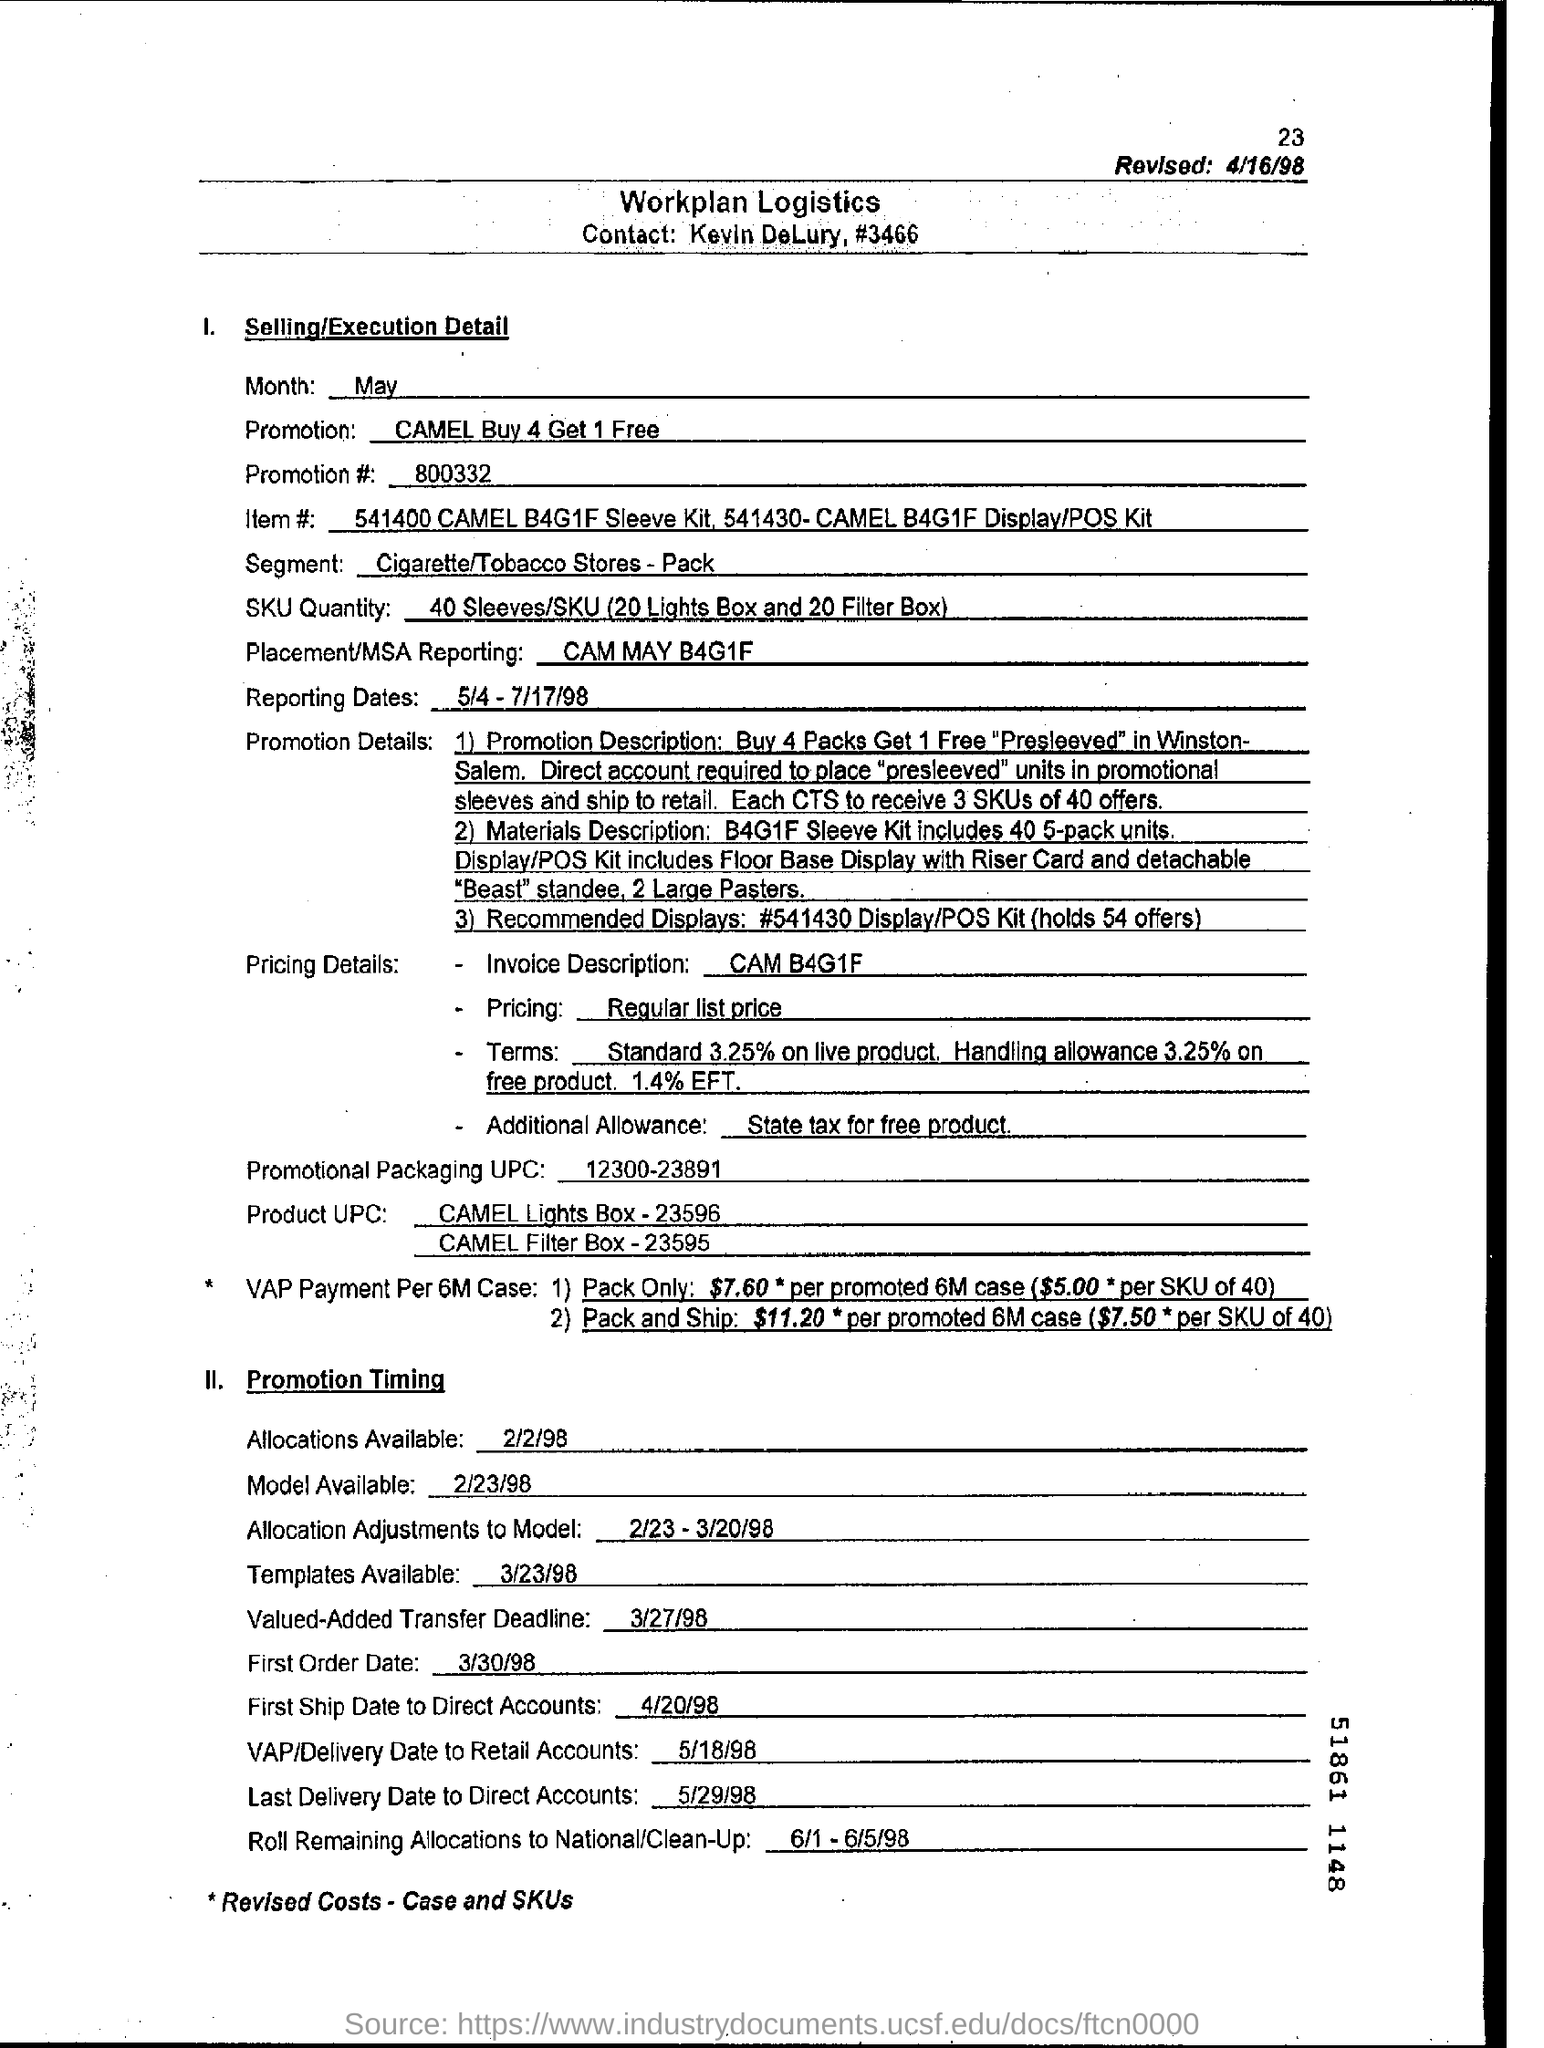Outline some significant characteristics in this image. The value-added transfer deadline is March 27, 1998. The segment for cigarette and tobacco stores includes packaging, which is a significant part of the industry. The promotion code is 800332... The reporting dates for a particular period are from May 4, 1998 to July 17, 1998. The first order date is March 30, 1998. 